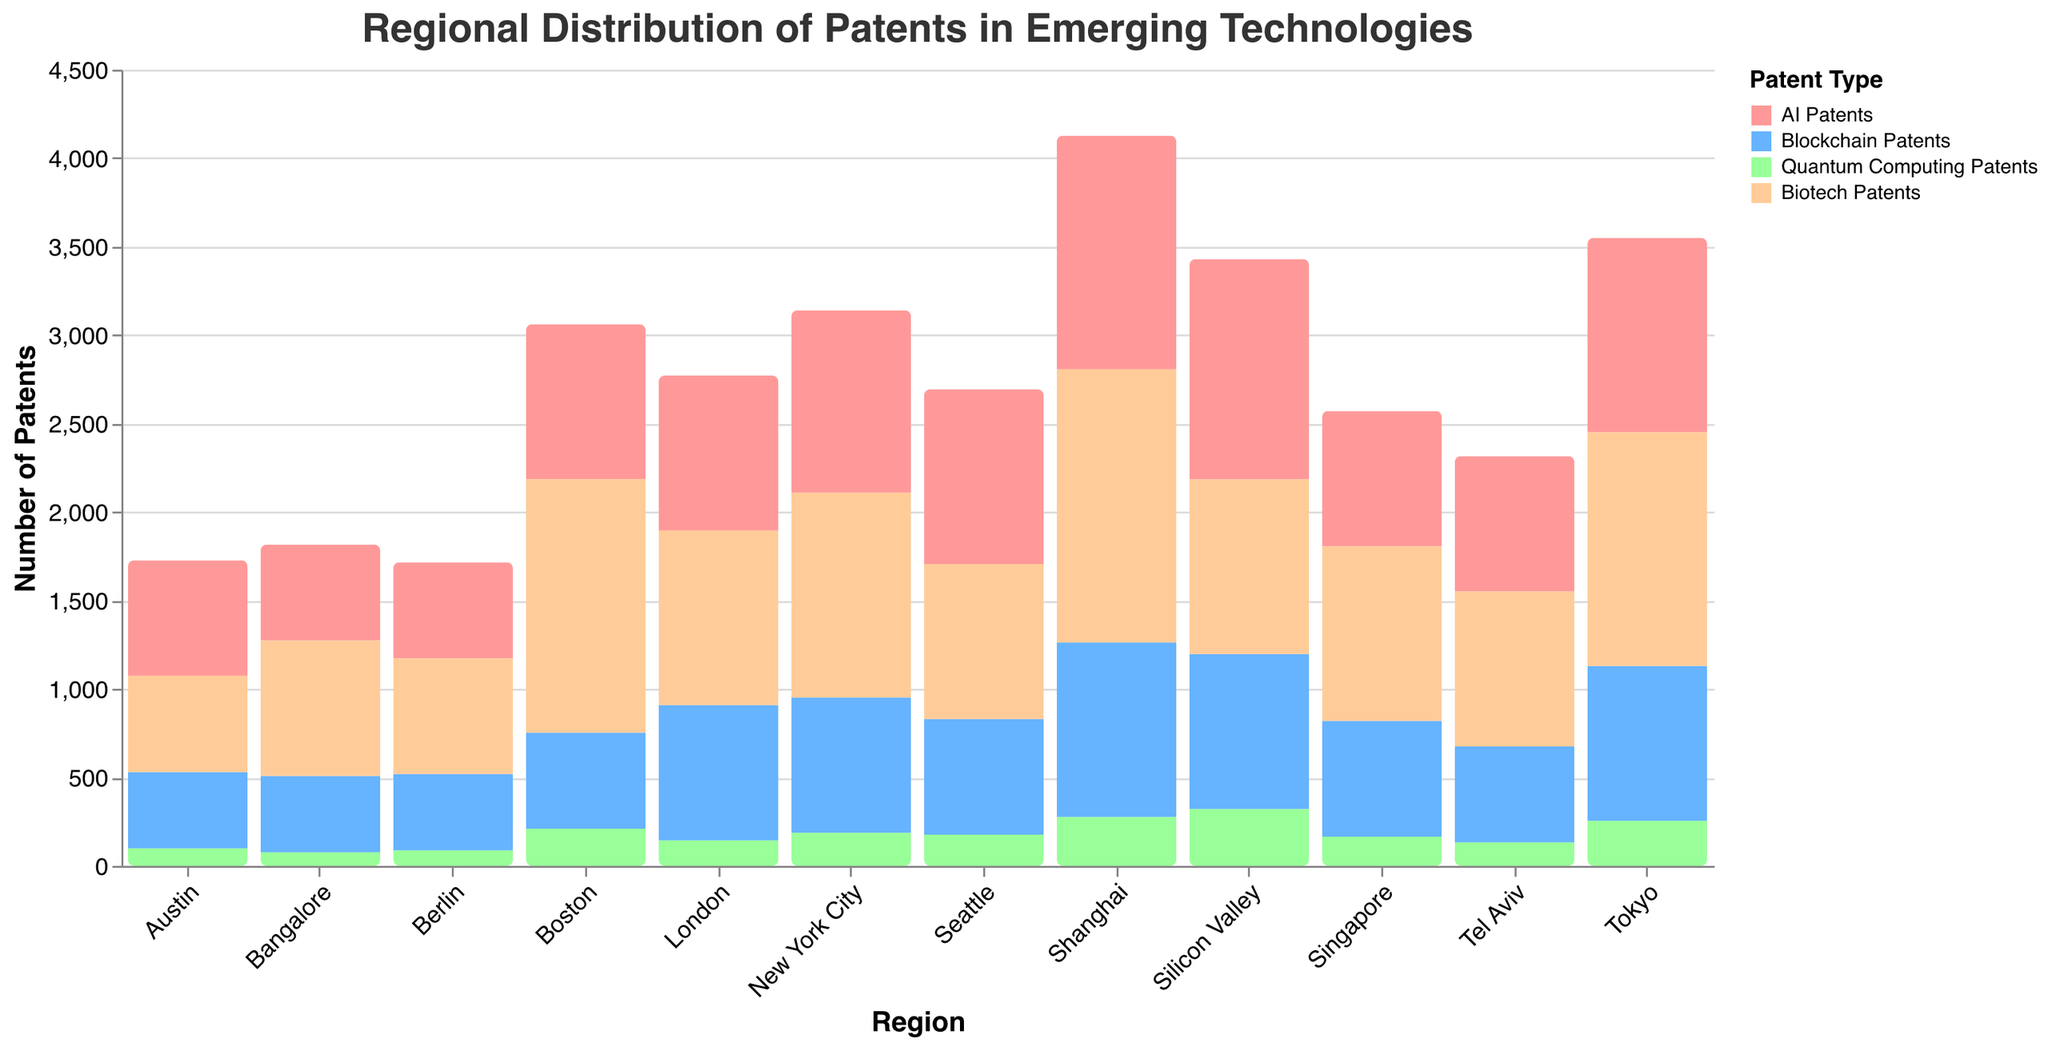Which region has the highest number of AI patents? According to the bar plot, Shanghai has the highest number of AI patents with 1321 patents filed
Answer: Shanghai Which city has filed more Blockchain patents, Tokyo or Tel Aviv? By comparing the height of the bars for Blockchain patents of Tokyo and Tel Aviv, Tokyo has 876 Blockchain patents while Tel Aviv has 543
Answer: Tokyo Which region has the lowest number of Quantum Computing patents? The bar corresponding to Bangalore for Quantum Computing patents is the shortest, indicating it has the lowest number with 76 patents filed
Answer: Bangalore What is the total number of Biotech patents filed by Silicon Valley and Boston? Add the values from the Biotech patents of Silicon Valley and Boston, which are 987 and 1432 respectively. 987 + 1432 = 2419
Answer: 2419 Which region has more AI patents than Quantum Computing patents but fewer than Biotech patents? Looking at the regions, New York City has AI patents (1032) greater than Quantum Computing patents (187) but fewer than Biotech patents (1156)
Answer: New York City How does the number of Blockchain patents in London compare to that of Seattle? Comparing the heights of the bars, London and Seattle both filed 765 Blockchain patents, so they are equal
Answer: Equal What is the average number of Quantum Computing patents filed across all regions? To find the average, sum the Quantum Computing patents from all regions and divide by the number of regions (321 + 210 + 187 + 98 + 176 + 143 + 87 + 132 + 254 + 165 + 276 + 76 = 2125). 2125 / 12 = 177.08
Answer: 177.08 Which region has filed more patents in Biotech compared to AI? By comparing the Biotech and AI patents for each region, Boston has more Biotech patents (1432) than AI patents (876)
Answer: Boston Which region leads in patents for emerging technologies overall? Adding the patents for all four technology types for each region, Shanghai leads with a total of 1321 (AI) + 987 (Blockchain) + 276 (Quantum Computing) + 1543 (Biotech) = 4127
Answer: Shanghai How many regions have filed more than 1000 AI patents? Counting the regions with more than 1000 patents in AI, we find Silicon Valley (1245), New York City (1032), and Shanghai (1321) meeting this criterion, so there are three regions
Answer: 3 